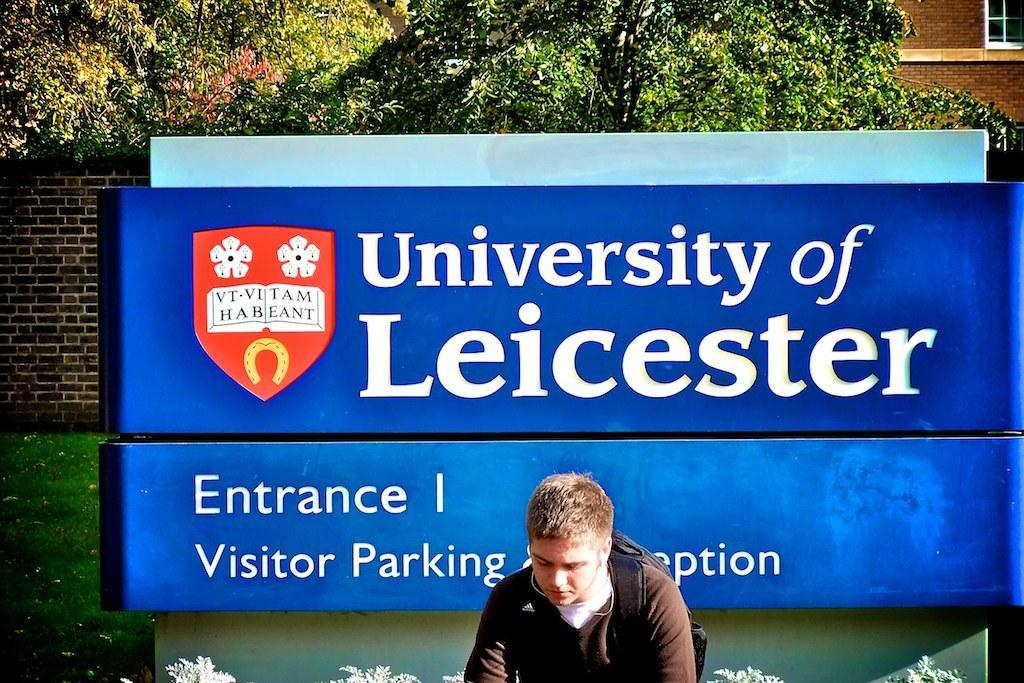<image>
Share a concise interpretation of the image provided. A blue sign for the entrance to a parking lot at University of Leicester 